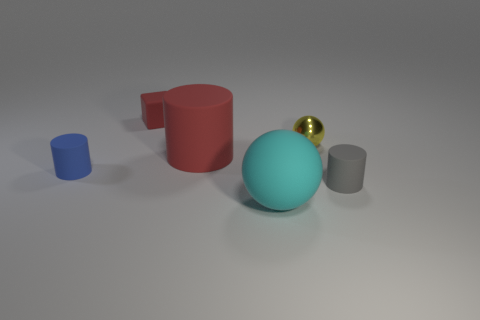Add 3 big yellow shiny things. How many objects exist? 9 Subtract all cubes. How many objects are left? 5 Subtract all purple metal cubes. Subtract all gray matte cylinders. How many objects are left? 5 Add 1 blue cylinders. How many blue cylinders are left? 2 Add 6 gray cylinders. How many gray cylinders exist? 7 Subtract 1 gray cylinders. How many objects are left? 5 